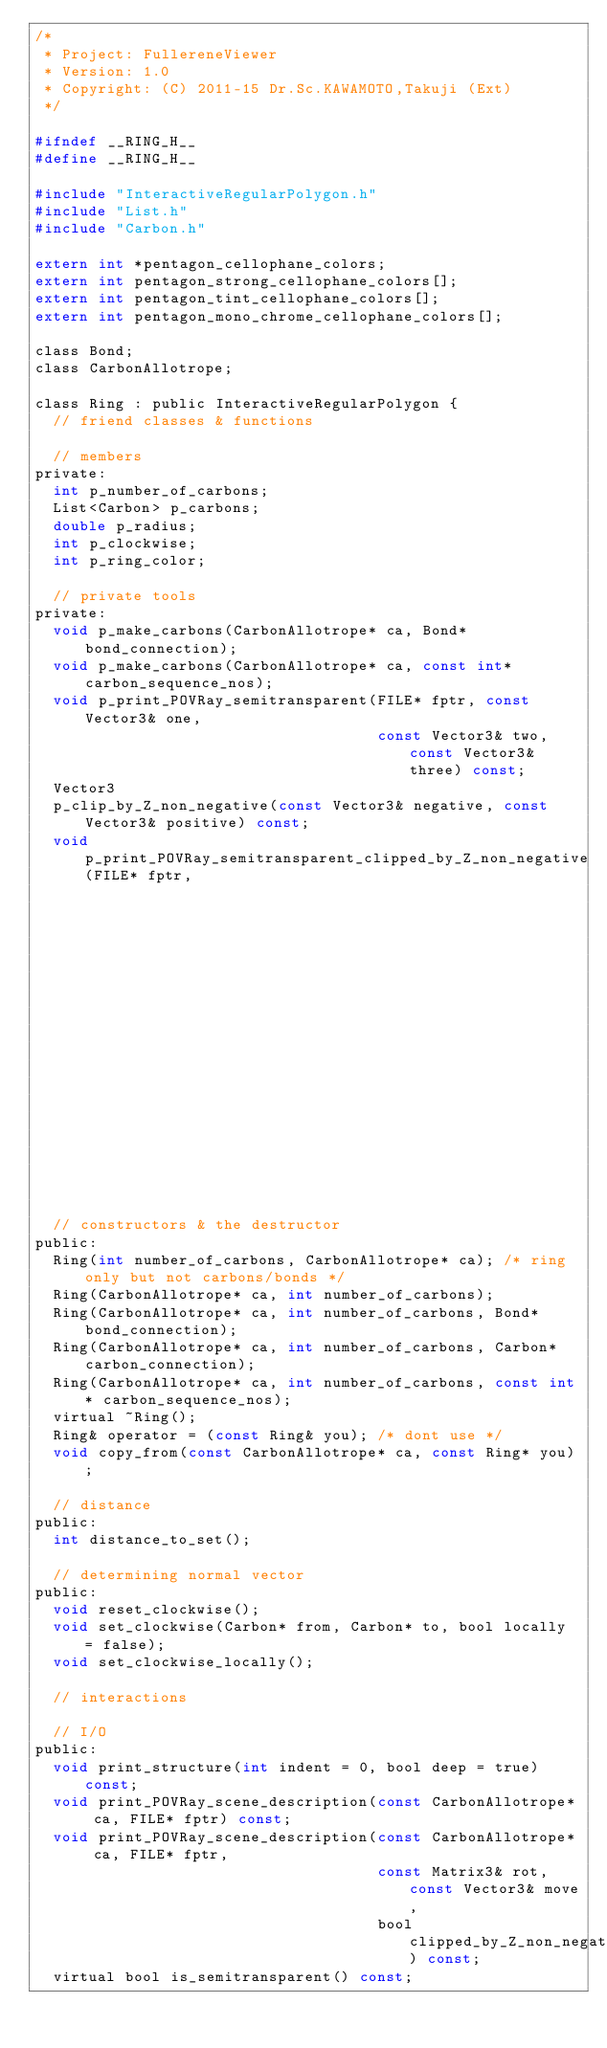<code> <loc_0><loc_0><loc_500><loc_500><_C_>/*
 * Project: FullereneViewer
 * Version: 1.0
 * Copyright: (C) 2011-15 Dr.Sc.KAWAMOTO,Takuji (Ext)
 */

#ifndef __RING_H__
#define __RING_H__

#include "InteractiveRegularPolygon.h"
#include "List.h"
#include "Carbon.h"

extern int *pentagon_cellophane_colors;
extern int pentagon_strong_cellophane_colors[];
extern int pentagon_tint_cellophane_colors[];
extern int pentagon_mono_chrome_cellophane_colors[];

class Bond;
class CarbonAllotrope;

class Ring : public InteractiveRegularPolygon {
  // friend classes & functions

  // members
private:
  int p_number_of_carbons;
  List<Carbon> p_carbons;
  double p_radius;
  int p_clockwise;
  int p_ring_color;

  // private tools
private:
  void p_make_carbons(CarbonAllotrope* ca, Bond* bond_connection);
  void p_make_carbons(CarbonAllotrope* ca, const int* carbon_sequence_nos);
  void p_print_POVRay_semitransparent(FILE* fptr, const Vector3& one,
                                      const Vector3& two, const Vector3& three) const;
  Vector3
  p_clip_by_Z_non_negative(const Vector3& negative, const Vector3& positive) const;
  void p_print_POVRay_semitransparent_clipped_by_Z_non_negative(FILE* fptr,
                                                                Vector3 one,
                                                                Vector3 two,
                                                                Vector3 three) const;

  // constructors & the destructor
public:
  Ring(int number_of_carbons, CarbonAllotrope* ca); /* ring only but not carbons/bonds */
  Ring(CarbonAllotrope* ca, int number_of_carbons);
  Ring(CarbonAllotrope* ca, int number_of_carbons, Bond* bond_connection);
  Ring(CarbonAllotrope* ca, int number_of_carbons, Carbon* carbon_connection);
  Ring(CarbonAllotrope* ca, int number_of_carbons, const int* carbon_sequence_nos);
  virtual ~Ring();
  Ring& operator = (const Ring& you); /* dont use */
  void copy_from(const CarbonAllotrope* ca, const Ring* you);

  // distance
public:
  int distance_to_set();

  // determining normal vector
public:
  void reset_clockwise();
  void set_clockwise(Carbon* from, Carbon* to, bool locally = false);
  void set_clockwise_locally();

  // interactions

  // I/O
public:
  void print_structure(int indent = 0, bool deep = true) const;
  void print_POVRay_scene_description(const CarbonAllotrope* ca, FILE* fptr) const;
  void print_POVRay_scene_description(const CarbonAllotrope* ca, FILE* fptr,
                                      const Matrix3& rot, const Vector3& move,
                                      bool clipped_by_Z_non_negative) const;
  virtual bool is_semitransparent() const;</code> 